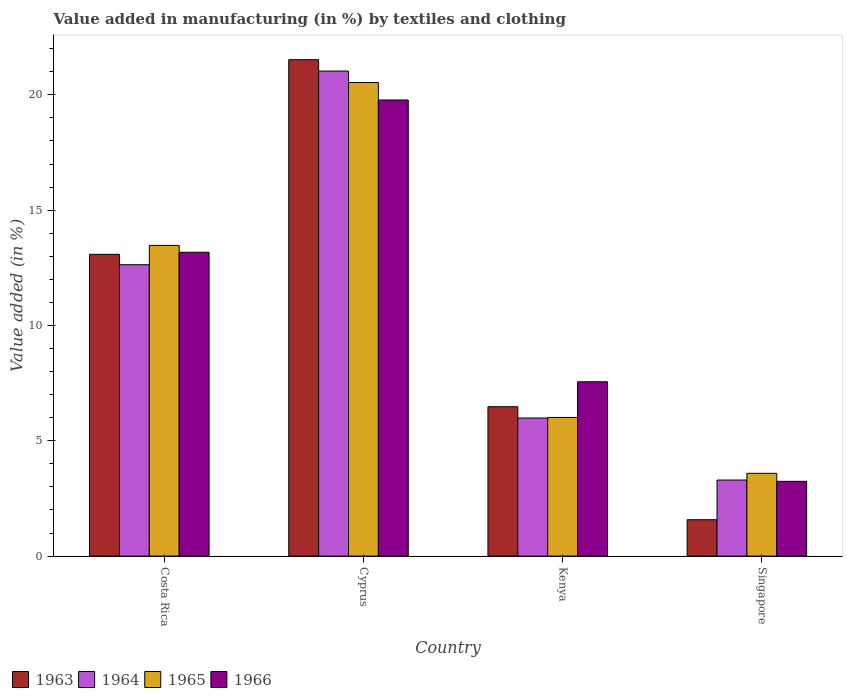How many groups of bars are there?
Make the answer very short. 4. Are the number of bars per tick equal to the number of legend labels?
Offer a very short reply. Yes. What is the label of the 1st group of bars from the left?
Offer a terse response. Costa Rica. In how many cases, is the number of bars for a given country not equal to the number of legend labels?
Give a very brief answer. 0. What is the percentage of value added in manufacturing by textiles and clothing in 1966 in Kenya?
Offer a terse response. 7.56. Across all countries, what is the maximum percentage of value added in manufacturing by textiles and clothing in 1964?
Your answer should be compact. 21.03. Across all countries, what is the minimum percentage of value added in manufacturing by textiles and clothing in 1963?
Give a very brief answer. 1.58. In which country was the percentage of value added in manufacturing by textiles and clothing in 1963 maximum?
Provide a short and direct response. Cyprus. In which country was the percentage of value added in manufacturing by textiles and clothing in 1964 minimum?
Ensure brevity in your answer.  Singapore. What is the total percentage of value added in manufacturing by textiles and clothing in 1965 in the graph?
Offer a terse response. 43.6. What is the difference between the percentage of value added in manufacturing by textiles and clothing in 1965 in Cyprus and that in Singapore?
Provide a short and direct response. 16.94. What is the difference between the percentage of value added in manufacturing by textiles and clothing in 1963 in Kenya and the percentage of value added in manufacturing by textiles and clothing in 1966 in Singapore?
Keep it short and to the point. 3.24. What is the average percentage of value added in manufacturing by textiles and clothing in 1964 per country?
Keep it short and to the point. 10.74. What is the difference between the percentage of value added in manufacturing by textiles and clothing of/in 1964 and percentage of value added in manufacturing by textiles and clothing of/in 1963 in Singapore?
Offer a very short reply. 1.72. In how many countries, is the percentage of value added in manufacturing by textiles and clothing in 1966 greater than 5 %?
Your answer should be very brief. 3. What is the ratio of the percentage of value added in manufacturing by textiles and clothing in 1966 in Costa Rica to that in Cyprus?
Your response must be concise. 0.67. Is the percentage of value added in manufacturing by textiles and clothing in 1964 in Kenya less than that in Singapore?
Your answer should be compact. No. Is the difference between the percentage of value added in manufacturing by textiles and clothing in 1964 in Costa Rica and Cyprus greater than the difference between the percentage of value added in manufacturing by textiles and clothing in 1963 in Costa Rica and Cyprus?
Your answer should be very brief. Yes. What is the difference between the highest and the second highest percentage of value added in manufacturing by textiles and clothing in 1965?
Your answer should be compact. 7.06. What is the difference between the highest and the lowest percentage of value added in manufacturing by textiles and clothing in 1966?
Offer a terse response. 16.53. Is the sum of the percentage of value added in manufacturing by textiles and clothing in 1963 in Kenya and Singapore greater than the maximum percentage of value added in manufacturing by textiles and clothing in 1966 across all countries?
Your answer should be very brief. No. What does the 2nd bar from the right in Costa Rica represents?
Ensure brevity in your answer.  1965. Is it the case that in every country, the sum of the percentage of value added in manufacturing by textiles and clothing in 1964 and percentage of value added in manufacturing by textiles and clothing in 1966 is greater than the percentage of value added in manufacturing by textiles and clothing in 1965?
Make the answer very short. Yes. Are all the bars in the graph horizontal?
Your answer should be very brief. No. How many countries are there in the graph?
Keep it short and to the point. 4. What is the difference between two consecutive major ticks on the Y-axis?
Your answer should be very brief. 5. Are the values on the major ticks of Y-axis written in scientific E-notation?
Your answer should be very brief. No. Does the graph contain grids?
Make the answer very short. No. Where does the legend appear in the graph?
Offer a terse response. Bottom left. How are the legend labels stacked?
Make the answer very short. Horizontal. What is the title of the graph?
Offer a terse response. Value added in manufacturing (in %) by textiles and clothing. What is the label or title of the Y-axis?
Provide a short and direct response. Value added (in %). What is the Value added (in %) in 1963 in Costa Rica?
Provide a short and direct response. 13.08. What is the Value added (in %) in 1964 in Costa Rica?
Give a very brief answer. 12.63. What is the Value added (in %) in 1965 in Costa Rica?
Make the answer very short. 13.47. What is the Value added (in %) of 1966 in Costa Rica?
Your response must be concise. 13.17. What is the Value added (in %) in 1963 in Cyprus?
Give a very brief answer. 21.52. What is the Value added (in %) in 1964 in Cyprus?
Your answer should be very brief. 21.03. What is the Value added (in %) in 1965 in Cyprus?
Provide a short and direct response. 20.53. What is the Value added (in %) in 1966 in Cyprus?
Your response must be concise. 19.78. What is the Value added (in %) of 1963 in Kenya?
Ensure brevity in your answer.  6.48. What is the Value added (in %) in 1964 in Kenya?
Offer a terse response. 5.99. What is the Value added (in %) of 1965 in Kenya?
Provide a succinct answer. 6.01. What is the Value added (in %) of 1966 in Kenya?
Ensure brevity in your answer.  7.56. What is the Value added (in %) of 1963 in Singapore?
Ensure brevity in your answer.  1.58. What is the Value added (in %) in 1964 in Singapore?
Offer a terse response. 3.3. What is the Value added (in %) of 1965 in Singapore?
Provide a short and direct response. 3.59. What is the Value added (in %) in 1966 in Singapore?
Offer a very short reply. 3.24. Across all countries, what is the maximum Value added (in %) in 1963?
Offer a very short reply. 21.52. Across all countries, what is the maximum Value added (in %) of 1964?
Ensure brevity in your answer.  21.03. Across all countries, what is the maximum Value added (in %) of 1965?
Ensure brevity in your answer.  20.53. Across all countries, what is the maximum Value added (in %) in 1966?
Provide a short and direct response. 19.78. Across all countries, what is the minimum Value added (in %) of 1963?
Give a very brief answer. 1.58. Across all countries, what is the minimum Value added (in %) of 1964?
Ensure brevity in your answer.  3.3. Across all countries, what is the minimum Value added (in %) in 1965?
Make the answer very short. 3.59. Across all countries, what is the minimum Value added (in %) of 1966?
Provide a short and direct response. 3.24. What is the total Value added (in %) of 1963 in the graph?
Make the answer very short. 42.66. What is the total Value added (in %) in 1964 in the graph?
Provide a short and direct response. 42.95. What is the total Value added (in %) in 1965 in the graph?
Provide a succinct answer. 43.6. What is the total Value added (in %) of 1966 in the graph?
Offer a terse response. 43.75. What is the difference between the Value added (in %) of 1963 in Costa Rica and that in Cyprus?
Your response must be concise. -8.44. What is the difference between the Value added (in %) of 1964 in Costa Rica and that in Cyprus?
Give a very brief answer. -8.4. What is the difference between the Value added (in %) of 1965 in Costa Rica and that in Cyprus?
Make the answer very short. -7.06. What is the difference between the Value added (in %) in 1966 in Costa Rica and that in Cyprus?
Your answer should be compact. -6.6. What is the difference between the Value added (in %) of 1963 in Costa Rica and that in Kenya?
Provide a short and direct response. 6.61. What is the difference between the Value added (in %) of 1964 in Costa Rica and that in Kenya?
Keep it short and to the point. 6.65. What is the difference between the Value added (in %) in 1965 in Costa Rica and that in Kenya?
Your answer should be very brief. 7.46. What is the difference between the Value added (in %) in 1966 in Costa Rica and that in Kenya?
Your response must be concise. 5.62. What is the difference between the Value added (in %) of 1963 in Costa Rica and that in Singapore?
Offer a very short reply. 11.51. What is the difference between the Value added (in %) of 1964 in Costa Rica and that in Singapore?
Give a very brief answer. 9.34. What is the difference between the Value added (in %) of 1965 in Costa Rica and that in Singapore?
Your answer should be very brief. 9.88. What is the difference between the Value added (in %) in 1966 in Costa Rica and that in Singapore?
Offer a very short reply. 9.93. What is the difference between the Value added (in %) in 1963 in Cyprus and that in Kenya?
Keep it short and to the point. 15.05. What is the difference between the Value added (in %) of 1964 in Cyprus and that in Kenya?
Your answer should be very brief. 15.04. What is the difference between the Value added (in %) in 1965 in Cyprus and that in Kenya?
Your response must be concise. 14.52. What is the difference between the Value added (in %) of 1966 in Cyprus and that in Kenya?
Your answer should be very brief. 12.22. What is the difference between the Value added (in %) of 1963 in Cyprus and that in Singapore?
Provide a succinct answer. 19.95. What is the difference between the Value added (in %) in 1964 in Cyprus and that in Singapore?
Your response must be concise. 17.73. What is the difference between the Value added (in %) of 1965 in Cyprus and that in Singapore?
Ensure brevity in your answer.  16.94. What is the difference between the Value added (in %) in 1966 in Cyprus and that in Singapore?
Offer a very short reply. 16.53. What is the difference between the Value added (in %) in 1963 in Kenya and that in Singapore?
Your answer should be very brief. 4.9. What is the difference between the Value added (in %) of 1964 in Kenya and that in Singapore?
Give a very brief answer. 2.69. What is the difference between the Value added (in %) in 1965 in Kenya and that in Singapore?
Your answer should be compact. 2.42. What is the difference between the Value added (in %) of 1966 in Kenya and that in Singapore?
Ensure brevity in your answer.  4.32. What is the difference between the Value added (in %) of 1963 in Costa Rica and the Value added (in %) of 1964 in Cyprus?
Provide a succinct answer. -7.95. What is the difference between the Value added (in %) in 1963 in Costa Rica and the Value added (in %) in 1965 in Cyprus?
Provide a short and direct response. -7.45. What is the difference between the Value added (in %) in 1963 in Costa Rica and the Value added (in %) in 1966 in Cyprus?
Offer a very short reply. -6.69. What is the difference between the Value added (in %) in 1964 in Costa Rica and the Value added (in %) in 1965 in Cyprus?
Offer a terse response. -7.9. What is the difference between the Value added (in %) in 1964 in Costa Rica and the Value added (in %) in 1966 in Cyprus?
Give a very brief answer. -7.14. What is the difference between the Value added (in %) in 1965 in Costa Rica and the Value added (in %) in 1966 in Cyprus?
Provide a short and direct response. -6.3. What is the difference between the Value added (in %) of 1963 in Costa Rica and the Value added (in %) of 1964 in Kenya?
Your answer should be very brief. 7.1. What is the difference between the Value added (in %) in 1963 in Costa Rica and the Value added (in %) in 1965 in Kenya?
Give a very brief answer. 7.07. What is the difference between the Value added (in %) in 1963 in Costa Rica and the Value added (in %) in 1966 in Kenya?
Provide a succinct answer. 5.53. What is the difference between the Value added (in %) of 1964 in Costa Rica and the Value added (in %) of 1965 in Kenya?
Give a very brief answer. 6.62. What is the difference between the Value added (in %) of 1964 in Costa Rica and the Value added (in %) of 1966 in Kenya?
Ensure brevity in your answer.  5.08. What is the difference between the Value added (in %) of 1965 in Costa Rica and the Value added (in %) of 1966 in Kenya?
Offer a very short reply. 5.91. What is the difference between the Value added (in %) of 1963 in Costa Rica and the Value added (in %) of 1964 in Singapore?
Your response must be concise. 9.79. What is the difference between the Value added (in %) of 1963 in Costa Rica and the Value added (in %) of 1965 in Singapore?
Your response must be concise. 9.5. What is the difference between the Value added (in %) of 1963 in Costa Rica and the Value added (in %) of 1966 in Singapore?
Give a very brief answer. 9.84. What is the difference between the Value added (in %) of 1964 in Costa Rica and the Value added (in %) of 1965 in Singapore?
Provide a short and direct response. 9.04. What is the difference between the Value added (in %) of 1964 in Costa Rica and the Value added (in %) of 1966 in Singapore?
Give a very brief answer. 9.39. What is the difference between the Value added (in %) of 1965 in Costa Rica and the Value added (in %) of 1966 in Singapore?
Offer a terse response. 10.23. What is the difference between the Value added (in %) of 1963 in Cyprus and the Value added (in %) of 1964 in Kenya?
Your response must be concise. 15.54. What is the difference between the Value added (in %) of 1963 in Cyprus and the Value added (in %) of 1965 in Kenya?
Provide a short and direct response. 15.51. What is the difference between the Value added (in %) of 1963 in Cyprus and the Value added (in %) of 1966 in Kenya?
Your answer should be compact. 13.97. What is the difference between the Value added (in %) in 1964 in Cyprus and the Value added (in %) in 1965 in Kenya?
Your answer should be compact. 15.02. What is the difference between the Value added (in %) in 1964 in Cyprus and the Value added (in %) in 1966 in Kenya?
Ensure brevity in your answer.  13.47. What is the difference between the Value added (in %) in 1965 in Cyprus and the Value added (in %) in 1966 in Kenya?
Keep it short and to the point. 12.97. What is the difference between the Value added (in %) of 1963 in Cyprus and the Value added (in %) of 1964 in Singapore?
Your response must be concise. 18.23. What is the difference between the Value added (in %) of 1963 in Cyprus and the Value added (in %) of 1965 in Singapore?
Provide a short and direct response. 17.93. What is the difference between the Value added (in %) of 1963 in Cyprus and the Value added (in %) of 1966 in Singapore?
Provide a succinct answer. 18.28. What is the difference between the Value added (in %) of 1964 in Cyprus and the Value added (in %) of 1965 in Singapore?
Provide a short and direct response. 17.44. What is the difference between the Value added (in %) of 1964 in Cyprus and the Value added (in %) of 1966 in Singapore?
Offer a terse response. 17.79. What is the difference between the Value added (in %) in 1965 in Cyprus and the Value added (in %) in 1966 in Singapore?
Offer a very short reply. 17.29. What is the difference between the Value added (in %) in 1963 in Kenya and the Value added (in %) in 1964 in Singapore?
Provide a short and direct response. 3.18. What is the difference between the Value added (in %) in 1963 in Kenya and the Value added (in %) in 1965 in Singapore?
Provide a succinct answer. 2.89. What is the difference between the Value added (in %) in 1963 in Kenya and the Value added (in %) in 1966 in Singapore?
Offer a terse response. 3.24. What is the difference between the Value added (in %) of 1964 in Kenya and the Value added (in %) of 1965 in Singapore?
Your answer should be very brief. 2.4. What is the difference between the Value added (in %) in 1964 in Kenya and the Value added (in %) in 1966 in Singapore?
Make the answer very short. 2.75. What is the difference between the Value added (in %) of 1965 in Kenya and the Value added (in %) of 1966 in Singapore?
Your response must be concise. 2.77. What is the average Value added (in %) in 1963 per country?
Provide a succinct answer. 10.67. What is the average Value added (in %) of 1964 per country?
Keep it short and to the point. 10.74. What is the average Value added (in %) of 1965 per country?
Give a very brief answer. 10.9. What is the average Value added (in %) of 1966 per country?
Provide a succinct answer. 10.94. What is the difference between the Value added (in %) of 1963 and Value added (in %) of 1964 in Costa Rica?
Your answer should be very brief. 0.45. What is the difference between the Value added (in %) of 1963 and Value added (in %) of 1965 in Costa Rica?
Make the answer very short. -0.39. What is the difference between the Value added (in %) in 1963 and Value added (in %) in 1966 in Costa Rica?
Offer a very short reply. -0.09. What is the difference between the Value added (in %) in 1964 and Value added (in %) in 1965 in Costa Rica?
Keep it short and to the point. -0.84. What is the difference between the Value added (in %) of 1964 and Value added (in %) of 1966 in Costa Rica?
Provide a short and direct response. -0.54. What is the difference between the Value added (in %) in 1965 and Value added (in %) in 1966 in Costa Rica?
Provide a succinct answer. 0.3. What is the difference between the Value added (in %) in 1963 and Value added (in %) in 1964 in Cyprus?
Make the answer very short. 0.49. What is the difference between the Value added (in %) of 1963 and Value added (in %) of 1966 in Cyprus?
Ensure brevity in your answer.  1.75. What is the difference between the Value added (in %) of 1964 and Value added (in %) of 1965 in Cyprus?
Your answer should be very brief. 0.5. What is the difference between the Value added (in %) in 1964 and Value added (in %) in 1966 in Cyprus?
Your answer should be very brief. 1.25. What is the difference between the Value added (in %) of 1965 and Value added (in %) of 1966 in Cyprus?
Offer a very short reply. 0.76. What is the difference between the Value added (in %) in 1963 and Value added (in %) in 1964 in Kenya?
Provide a succinct answer. 0.49. What is the difference between the Value added (in %) of 1963 and Value added (in %) of 1965 in Kenya?
Offer a terse response. 0.47. What is the difference between the Value added (in %) in 1963 and Value added (in %) in 1966 in Kenya?
Your answer should be very brief. -1.08. What is the difference between the Value added (in %) of 1964 and Value added (in %) of 1965 in Kenya?
Your response must be concise. -0.02. What is the difference between the Value added (in %) of 1964 and Value added (in %) of 1966 in Kenya?
Make the answer very short. -1.57. What is the difference between the Value added (in %) of 1965 and Value added (in %) of 1966 in Kenya?
Give a very brief answer. -1.55. What is the difference between the Value added (in %) of 1963 and Value added (in %) of 1964 in Singapore?
Provide a succinct answer. -1.72. What is the difference between the Value added (in %) in 1963 and Value added (in %) in 1965 in Singapore?
Provide a short and direct response. -2.01. What is the difference between the Value added (in %) of 1963 and Value added (in %) of 1966 in Singapore?
Provide a short and direct response. -1.66. What is the difference between the Value added (in %) of 1964 and Value added (in %) of 1965 in Singapore?
Your answer should be very brief. -0.29. What is the difference between the Value added (in %) in 1964 and Value added (in %) in 1966 in Singapore?
Offer a very short reply. 0.06. What is the difference between the Value added (in %) in 1965 and Value added (in %) in 1966 in Singapore?
Offer a terse response. 0.35. What is the ratio of the Value added (in %) of 1963 in Costa Rica to that in Cyprus?
Your answer should be very brief. 0.61. What is the ratio of the Value added (in %) in 1964 in Costa Rica to that in Cyprus?
Make the answer very short. 0.6. What is the ratio of the Value added (in %) in 1965 in Costa Rica to that in Cyprus?
Provide a succinct answer. 0.66. What is the ratio of the Value added (in %) in 1966 in Costa Rica to that in Cyprus?
Your answer should be very brief. 0.67. What is the ratio of the Value added (in %) in 1963 in Costa Rica to that in Kenya?
Your response must be concise. 2.02. What is the ratio of the Value added (in %) of 1964 in Costa Rica to that in Kenya?
Your answer should be compact. 2.11. What is the ratio of the Value added (in %) in 1965 in Costa Rica to that in Kenya?
Provide a short and direct response. 2.24. What is the ratio of the Value added (in %) of 1966 in Costa Rica to that in Kenya?
Provide a short and direct response. 1.74. What is the ratio of the Value added (in %) of 1963 in Costa Rica to that in Singapore?
Keep it short and to the point. 8.3. What is the ratio of the Value added (in %) of 1964 in Costa Rica to that in Singapore?
Your answer should be compact. 3.83. What is the ratio of the Value added (in %) of 1965 in Costa Rica to that in Singapore?
Your response must be concise. 3.75. What is the ratio of the Value added (in %) in 1966 in Costa Rica to that in Singapore?
Provide a succinct answer. 4.06. What is the ratio of the Value added (in %) in 1963 in Cyprus to that in Kenya?
Offer a terse response. 3.32. What is the ratio of the Value added (in %) in 1964 in Cyprus to that in Kenya?
Your response must be concise. 3.51. What is the ratio of the Value added (in %) in 1965 in Cyprus to that in Kenya?
Your response must be concise. 3.42. What is the ratio of the Value added (in %) in 1966 in Cyprus to that in Kenya?
Ensure brevity in your answer.  2.62. What is the ratio of the Value added (in %) in 1963 in Cyprus to that in Singapore?
Provide a short and direct response. 13.65. What is the ratio of the Value added (in %) in 1964 in Cyprus to that in Singapore?
Give a very brief answer. 6.38. What is the ratio of the Value added (in %) in 1965 in Cyprus to that in Singapore?
Your answer should be compact. 5.72. What is the ratio of the Value added (in %) in 1966 in Cyprus to that in Singapore?
Make the answer very short. 6.1. What is the ratio of the Value added (in %) of 1963 in Kenya to that in Singapore?
Your answer should be very brief. 4.11. What is the ratio of the Value added (in %) of 1964 in Kenya to that in Singapore?
Provide a short and direct response. 1.82. What is the ratio of the Value added (in %) of 1965 in Kenya to that in Singapore?
Give a very brief answer. 1.67. What is the ratio of the Value added (in %) of 1966 in Kenya to that in Singapore?
Your answer should be compact. 2.33. What is the difference between the highest and the second highest Value added (in %) of 1963?
Offer a terse response. 8.44. What is the difference between the highest and the second highest Value added (in %) in 1964?
Your answer should be very brief. 8.4. What is the difference between the highest and the second highest Value added (in %) in 1965?
Provide a short and direct response. 7.06. What is the difference between the highest and the second highest Value added (in %) in 1966?
Provide a succinct answer. 6.6. What is the difference between the highest and the lowest Value added (in %) of 1963?
Offer a very short reply. 19.95. What is the difference between the highest and the lowest Value added (in %) of 1964?
Your answer should be compact. 17.73. What is the difference between the highest and the lowest Value added (in %) of 1965?
Provide a short and direct response. 16.94. What is the difference between the highest and the lowest Value added (in %) of 1966?
Your answer should be compact. 16.53. 